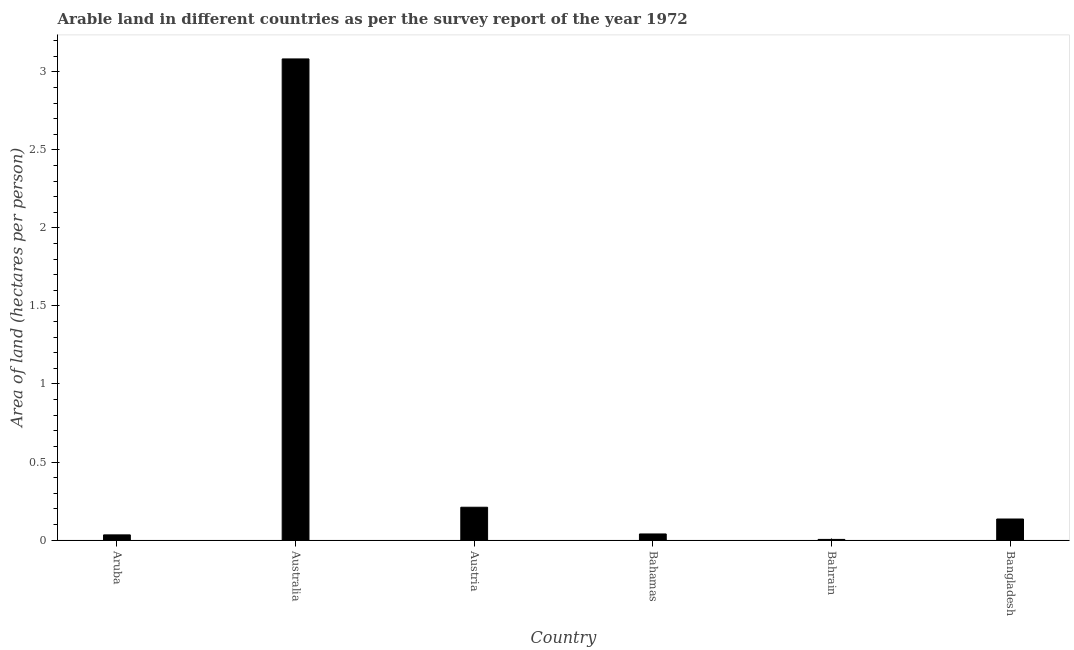Does the graph contain grids?
Your answer should be very brief. No. What is the title of the graph?
Your response must be concise. Arable land in different countries as per the survey report of the year 1972. What is the label or title of the X-axis?
Ensure brevity in your answer.  Country. What is the label or title of the Y-axis?
Your answer should be very brief. Area of land (hectares per person). What is the area of arable land in Bangladesh?
Your response must be concise. 0.14. Across all countries, what is the maximum area of arable land?
Offer a very short reply. 3.08. Across all countries, what is the minimum area of arable land?
Make the answer very short. 0. In which country was the area of arable land maximum?
Offer a terse response. Australia. In which country was the area of arable land minimum?
Offer a terse response. Bahrain. What is the sum of the area of arable land?
Make the answer very short. 3.51. What is the difference between the area of arable land in Australia and Bahrain?
Make the answer very short. 3.08. What is the average area of arable land per country?
Keep it short and to the point. 0.58. What is the median area of arable land?
Offer a very short reply. 0.09. What is the ratio of the area of arable land in Australia to that in Bangladesh?
Keep it short and to the point. 22.81. Is the area of arable land in Aruba less than that in Bahrain?
Make the answer very short. No. Is the difference between the area of arable land in Austria and Bangladesh greater than the difference between any two countries?
Your answer should be very brief. No. What is the difference between the highest and the second highest area of arable land?
Provide a short and direct response. 2.87. What is the difference between the highest and the lowest area of arable land?
Provide a short and direct response. 3.08. In how many countries, is the area of arable land greater than the average area of arable land taken over all countries?
Offer a very short reply. 1. How many bars are there?
Provide a succinct answer. 6. Are all the bars in the graph horizontal?
Provide a short and direct response. No. What is the difference between two consecutive major ticks on the Y-axis?
Your answer should be very brief. 0.5. Are the values on the major ticks of Y-axis written in scientific E-notation?
Make the answer very short. No. What is the Area of land (hectares per person) in Aruba?
Keep it short and to the point. 0.03. What is the Area of land (hectares per person) in Australia?
Your answer should be very brief. 3.08. What is the Area of land (hectares per person) in Austria?
Keep it short and to the point. 0.21. What is the Area of land (hectares per person) of Bahamas?
Your answer should be very brief. 0.04. What is the Area of land (hectares per person) in Bahrain?
Offer a terse response. 0. What is the Area of land (hectares per person) of Bangladesh?
Ensure brevity in your answer.  0.14. What is the difference between the Area of land (hectares per person) in Aruba and Australia?
Offer a very short reply. -3.05. What is the difference between the Area of land (hectares per person) in Aruba and Austria?
Your answer should be compact. -0.18. What is the difference between the Area of land (hectares per person) in Aruba and Bahamas?
Your response must be concise. -0.01. What is the difference between the Area of land (hectares per person) in Aruba and Bahrain?
Make the answer very short. 0.03. What is the difference between the Area of land (hectares per person) in Aruba and Bangladesh?
Ensure brevity in your answer.  -0.1. What is the difference between the Area of land (hectares per person) in Australia and Austria?
Your response must be concise. 2.87. What is the difference between the Area of land (hectares per person) in Australia and Bahamas?
Ensure brevity in your answer.  3.04. What is the difference between the Area of land (hectares per person) in Australia and Bahrain?
Offer a terse response. 3.08. What is the difference between the Area of land (hectares per person) in Australia and Bangladesh?
Make the answer very short. 2.95. What is the difference between the Area of land (hectares per person) in Austria and Bahamas?
Provide a short and direct response. 0.17. What is the difference between the Area of land (hectares per person) in Austria and Bahrain?
Provide a succinct answer. 0.21. What is the difference between the Area of land (hectares per person) in Austria and Bangladesh?
Offer a terse response. 0.08. What is the difference between the Area of land (hectares per person) in Bahamas and Bahrain?
Make the answer very short. 0.04. What is the difference between the Area of land (hectares per person) in Bahamas and Bangladesh?
Provide a short and direct response. -0.1. What is the difference between the Area of land (hectares per person) in Bahrain and Bangladesh?
Your answer should be very brief. -0.13. What is the ratio of the Area of land (hectares per person) in Aruba to that in Australia?
Your response must be concise. 0.01. What is the ratio of the Area of land (hectares per person) in Aruba to that in Austria?
Your answer should be compact. 0.16. What is the ratio of the Area of land (hectares per person) in Aruba to that in Bahamas?
Your answer should be very brief. 0.85. What is the ratio of the Area of land (hectares per person) in Aruba to that in Bahrain?
Make the answer very short. 7.67. What is the ratio of the Area of land (hectares per person) in Aruba to that in Bangladesh?
Ensure brevity in your answer.  0.25. What is the ratio of the Area of land (hectares per person) in Australia to that in Austria?
Keep it short and to the point. 14.64. What is the ratio of the Area of land (hectares per person) in Australia to that in Bahamas?
Offer a very short reply. 78.31. What is the ratio of the Area of land (hectares per person) in Australia to that in Bahrain?
Provide a succinct answer. 707.67. What is the ratio of the Area of land (hectares per person) in Australia to that in Bangladesh?
Offer a terse response. 22.81. What is the ratio of the Area of land (hectares per person) in Austria to that in Bahamas?
Give a very brief answer. 5.35. What is the ratio of the Area of land (hectares per person) in Austria to that in Bahrain?
Provide a short and direct response. 48.33. What is the ratio of the Area of land (hectares per person) in Austria to that in Bangladesh?
Offer a terse response. 1.56. What is the ratio of the Area of land (hectares per person) in Bahamas to that in Bahrain?
Make the answer very short. 9.04. What is the ratio of the Area of land (hectares per person) in Bahamas to that in Bangladesh?
Give a very brief answer. 0.29. What is the ratio of the Area of land (hectares per person) in Bahrain to that in Bangladesh?
Offer a very short reply. 0.03. 